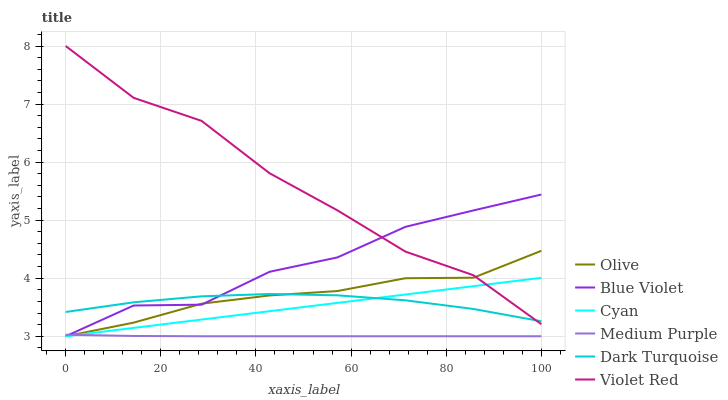Does Medium Purple have the minimum area under the curve?
Answer yes or no. Yes. Does Violet Red have the maximum area under the curve?
Answer yes or no. Yes. Does Dark Turquoise have the minimum area under the curve?
Answer yes or no. No. Does Dark Turquoise have the maximum area under the curve?
Answer yes or no. No. Is Cyan the smoothest?
Answer yes or no. Yes. Is Violet Red the roughest?
Answer yes or no. Yes. Is Dark Turquoise the smoothest?
Answer yes or no. No. Is Dark Turquoise the roughest?
Answer yes or no. No. Does Medium Purple have the lowest value?
Answer yes or no. Yes. Does Dark Turquoise have the lowest value?
Answer yes or no. No. Does Violet Red have the highest value?
Answer yes or no. Yes. Does Dark Turquoise have the highest value?
Answer yes or no. No. Is Medium Purple less than Dark Turquoise?
Answer yes or no. Yes. Is Dark Turquoise greater than Medium Purple?
Answer yes or no. Yes. Does Blue Violet intersect Olive?
Answer yes or no. Yes. Is Blue Violet less than Olive?
Answer yes or no. No. Is Blue Violet greater than Olive?
Answer yes or no. No. Does Medium Purple intersect Dark Turquoise?
Answer yes or no. No. 